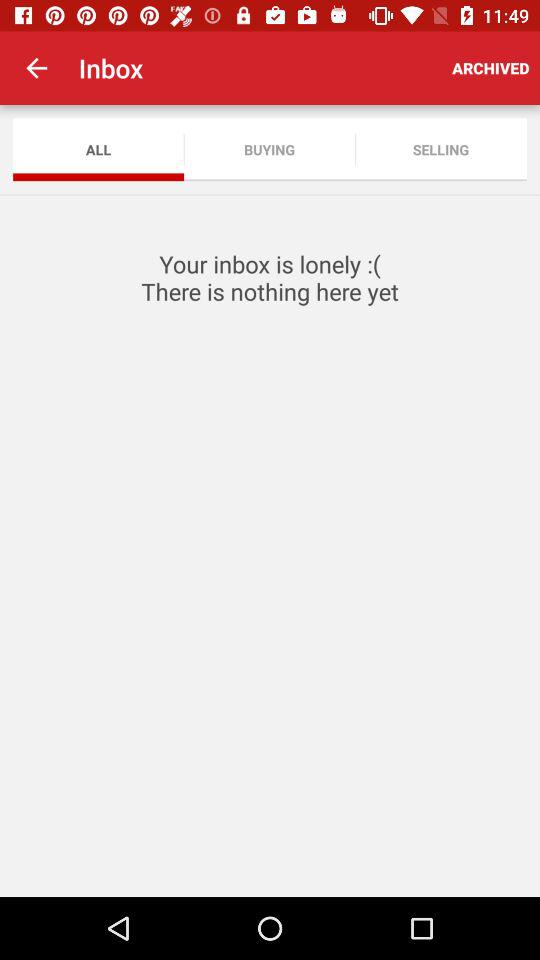What is the selected tab? The selected tab is "ALL". 